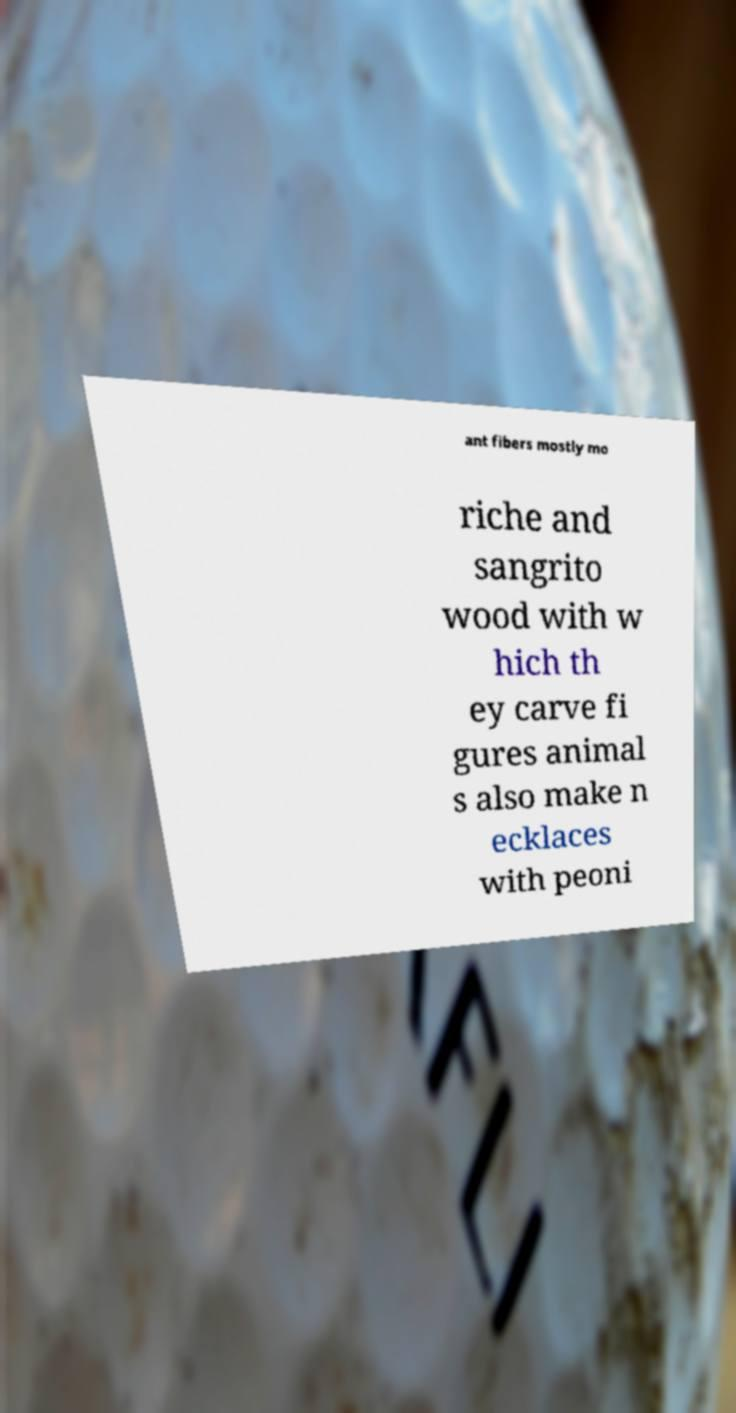Please identify and transcribe the text found in this image. ant fibers mostly mo riche and sangrito wood with w hich th ey carve fi gures animal s also make n ecklaces with peoni 